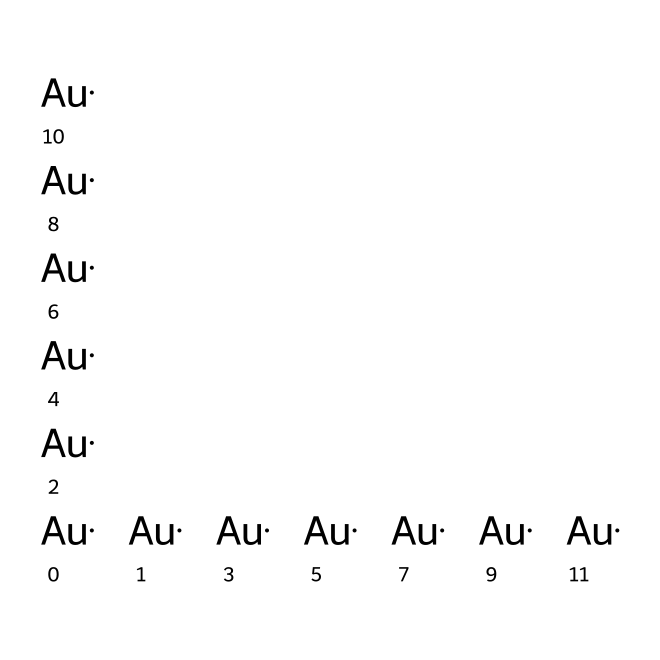What elements are present in this chemical structure? The SMILES representation shows only one type of element, which is gold, indicated by the symbol "Au." Therefore, the elements in this chemical structure are solely gold atoms.
Answer: gold How many gold atoms are represented in this structure? The SMILES string lists "Au" eleven times, indicating that there are eleven individual gold atoms present in this chemical structure.
Answer: eleven What is the common use of this type of nanoparticle? Gold nanoparticles are commonly used in rapid diagnostic tests, particularly in community health screenings, due to their ability to facilitate visual detection of analytes.
Answer: diagnostic tests Can this chemical be classified as a nanomaterial? Gold nanoparticles fall under the category of nanomaterials because they are nanoscale materials, typically defined as having at least one dimension measuring between 1 to 100 nanometers.
Answer: yes What structural feature allows gold nanoparticles to interact with biomolecules? The large surface area-to-volume ratio of gold nanoparticles allows them to effectively interact with biomolecules for various applications, including diagnostics and drug delivery.
Answer: surface area What is the primary reason gold is used in these nanoparticles? Gold is used in nanoparticles because of its biocompatibility, stability, and strong optical properties, making it ideal for use in biomedical applications.
Answer: biocompatibility 